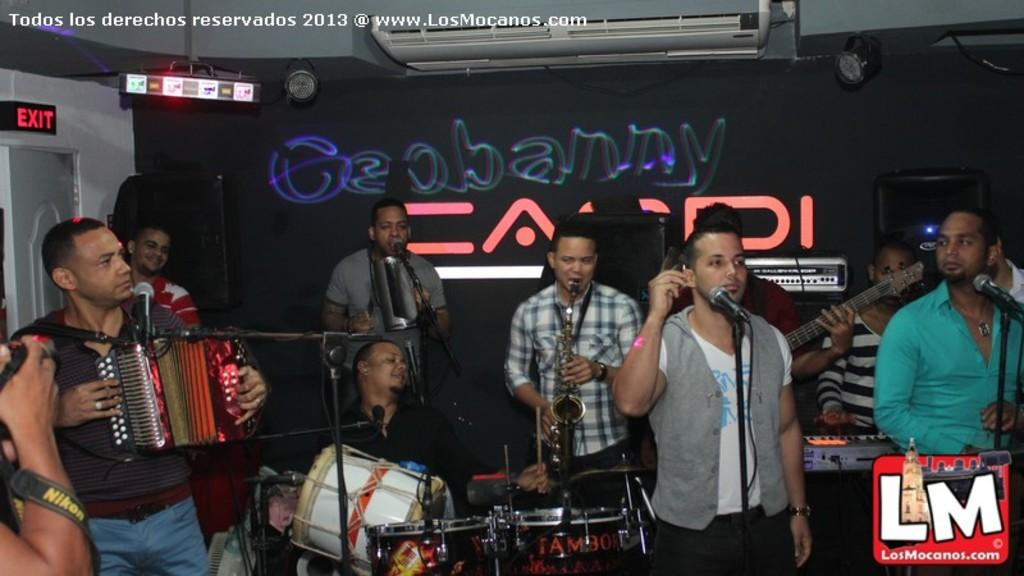What are the people in the image doing? The people in the image are playing musical instruments. Can you describe the setting of the image? There is a door and an object on the wall in the image. Additionally, there is an air conditioner on the wall. What type of alley can be seen behind the group of people in the image? There is no alley visible in the image; it only shows a group of people playing musical instruments and the mentioned objects in the setting. 